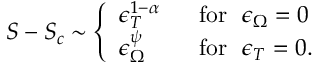<formula> <loc_0><loc_0><loc_500><loc_500>S - S _ { c } \sim \left \{ \begin{array} { l l } { { \epsilon _ { T } ^ { 1 - \alpha } } } & { { \ \ f o r \quad e p s i l o n _ { \Omega } = 0 } } \\ { { \epsilon _ { \Omega } ^ { \psi } } } & { { \ \ f o r \quad e p s i l o n _ { T } = 0 . } } \end{array}</formula> 